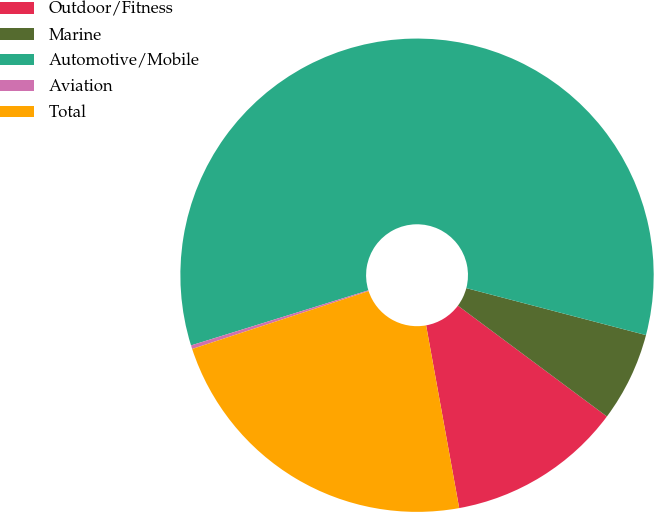<chart> <loc_0><loc_0><loc_500><loc_500><pie_chart><fcel>Outdoor/Fitness<fcel>Marine<fcel>Automotive/Mobile<fcel>Aviation<fcel>Total<nl><fcel>11.97%<fcel>6.11%<fcel>58.87%<fcel>0.25%<fcel>22.81%<nl></chart> 